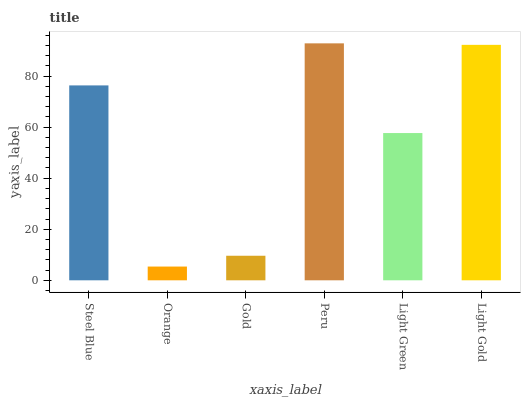Is Orange the minimum?
Answer yes or no. Yes. Is Peru the maximum?
Answer yes or no. Yes. Is Gold the minimum?
Answer yes or no. No. Is Gold the maximum?
Answer yes or no. No. Is Gold greater than Orange?
Answer yes or no. Yes. Is Orange less than Gold?
Answer yes or no. Yes. Is Orange greater than Gold?
Answer yes or no. No. Is Gold less than Orange?
Answer yes or no. No. Is Steel Blue the high median?
Answer yes or no. Yes. Is Light Green the low median?
Answer yes or no. Yes. Is Peru the high median?
Answer yes or no. No. Is Gold the low median?
Answer yes or no. No. 